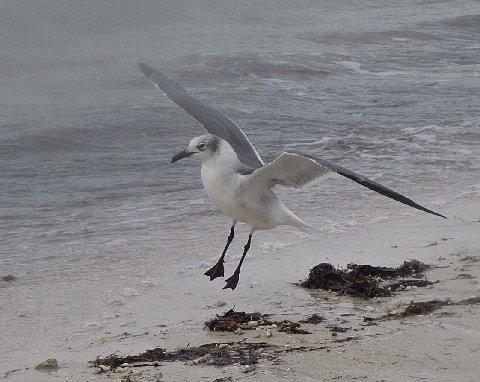What type of bird?
Quick response, please. Seagull. What type of feet does the bird have?
Give a very brief answer. Webbed. What color is the bird?
Short answer required. White. Is the birds mouth opened or closed?
Write a very short answer. Closed. What kind of bird is this?
Short answer required. Seagull. What is the bird looking for?
Give a very brief answer. Food. Is this seagull landing?
Keep it brief. Yes. How many birds are in the picture?
Be succinct. 1. 